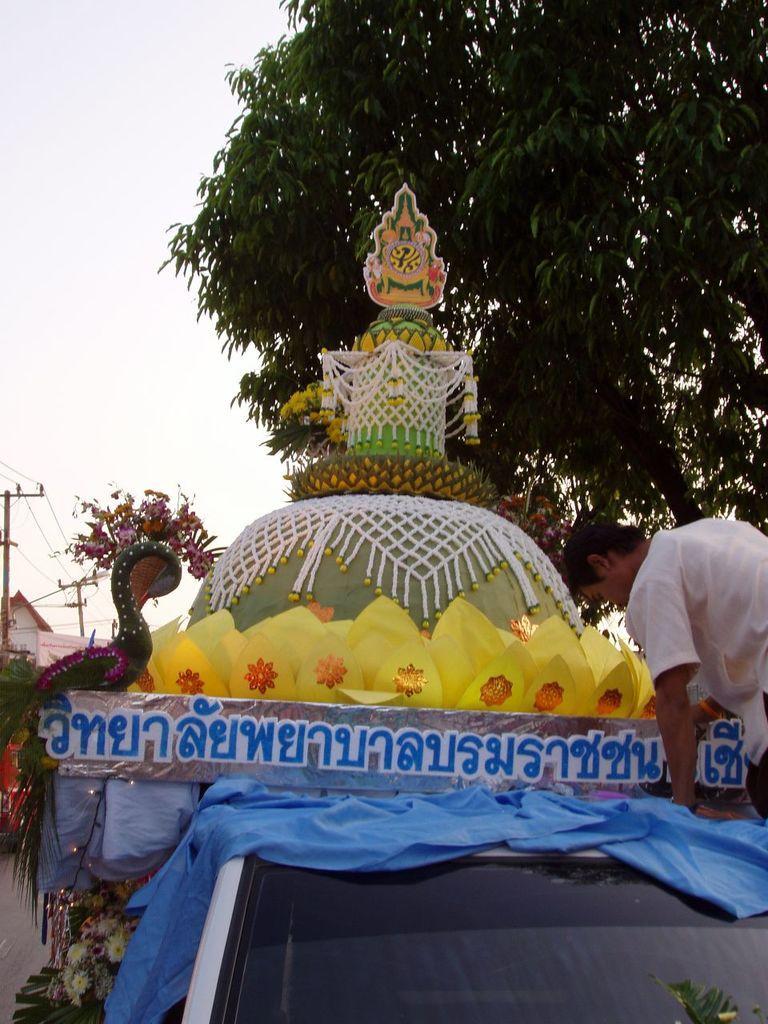How would you summarize this image in a sentence or two? In the image there is some artificial decoration and in front of the declaration there is a man on the right side, in the background there is a tree and on the left side there is a current pole and behind that there is a house. 